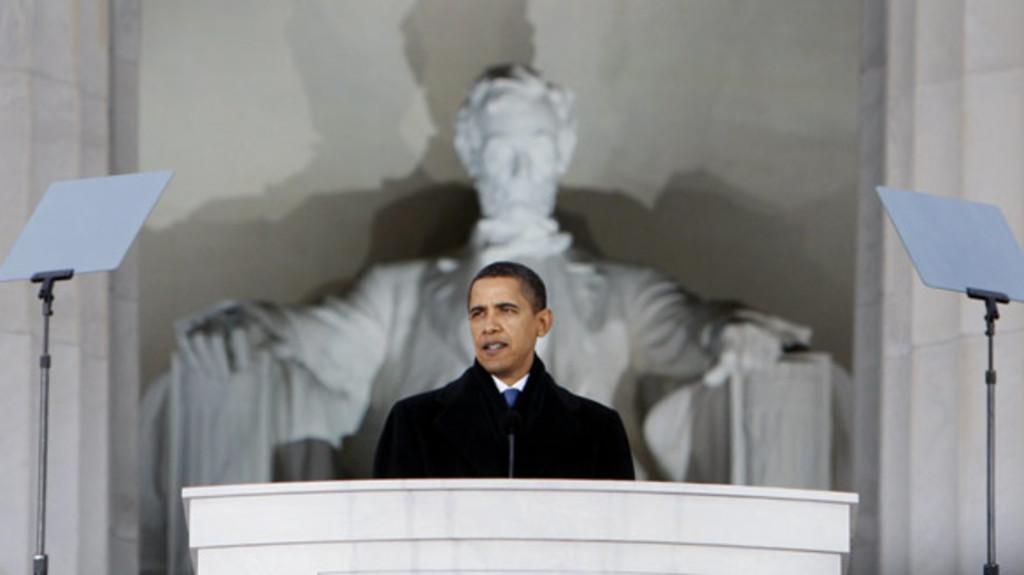Could you give a brief overview of what you see in this image? In this picture we can see a person in front of a podium. There is a microphone visible on this podium. We can see a few objects on the right and left side of the image. There is a statue and some shadows visible on a white background. 